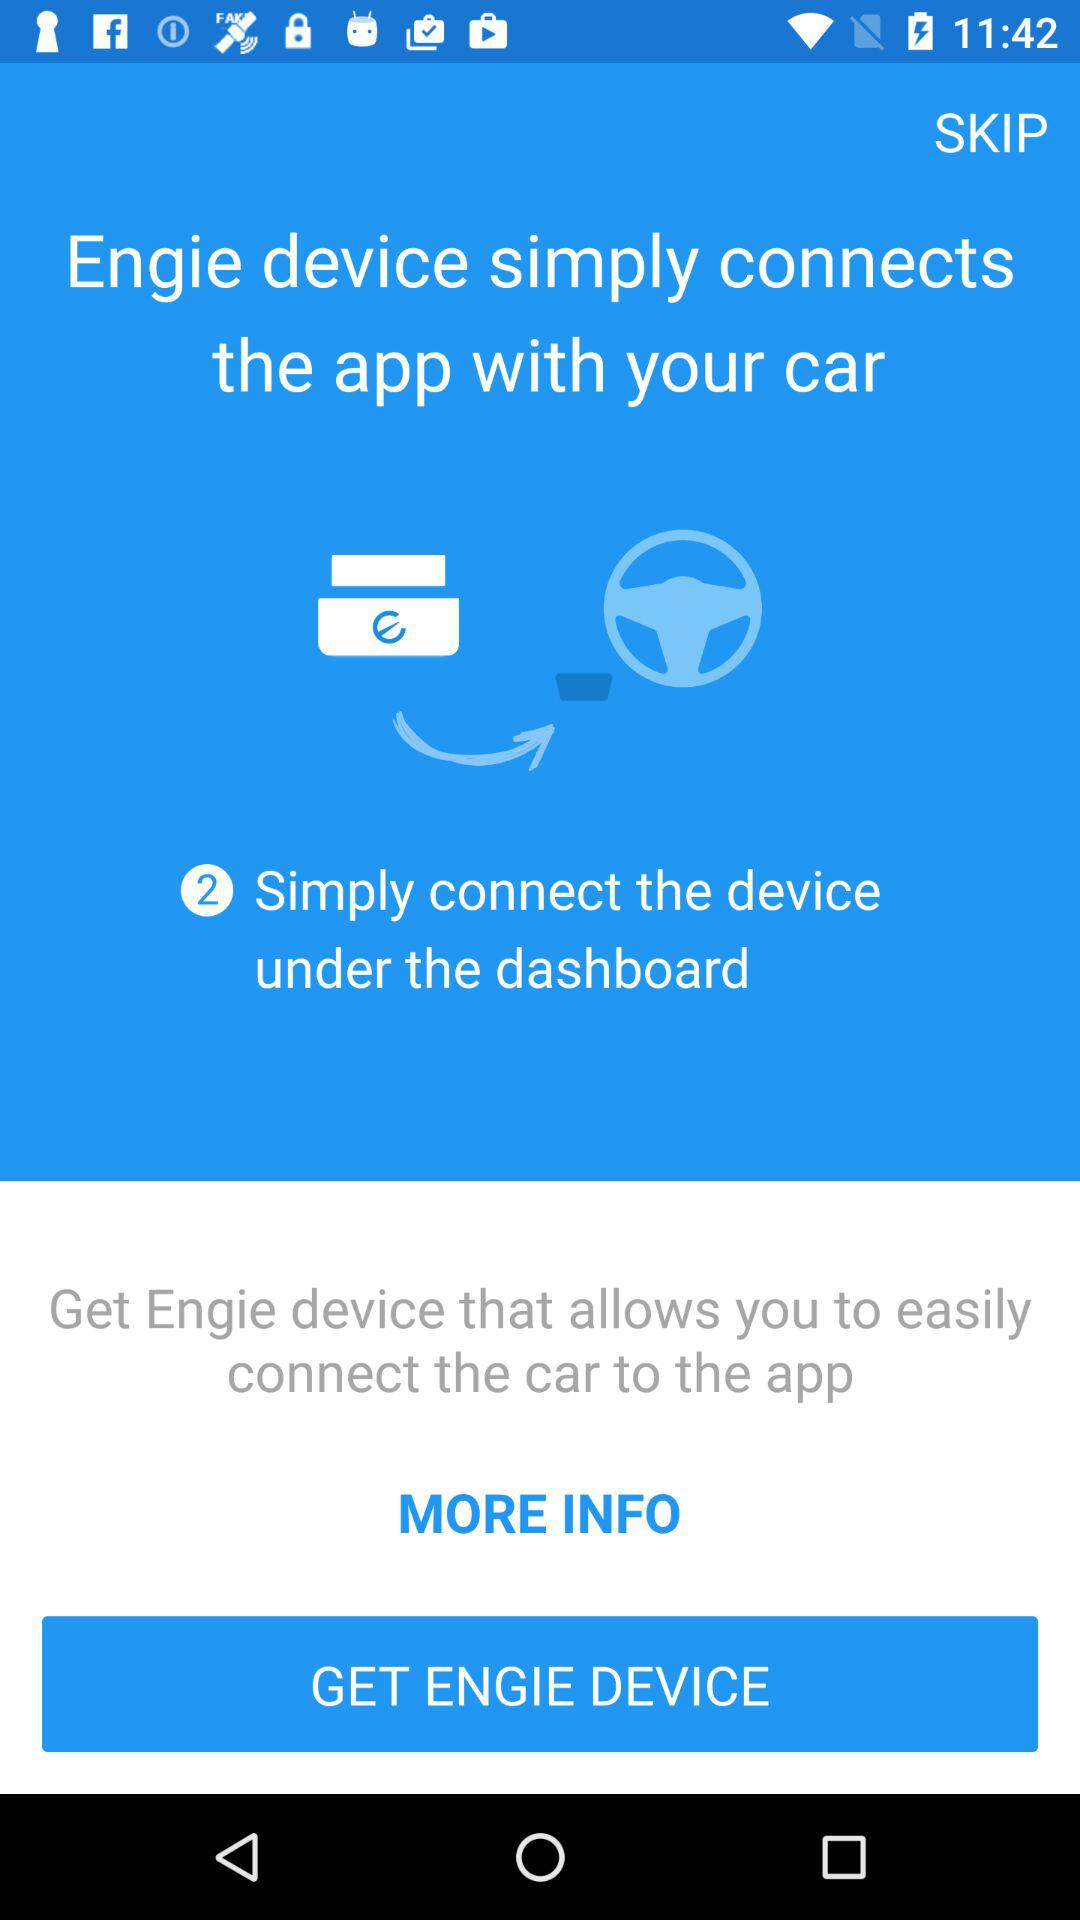What thing allows the application to connect with the car? The thing that allows the application to connect with the car is the "Engie device". 